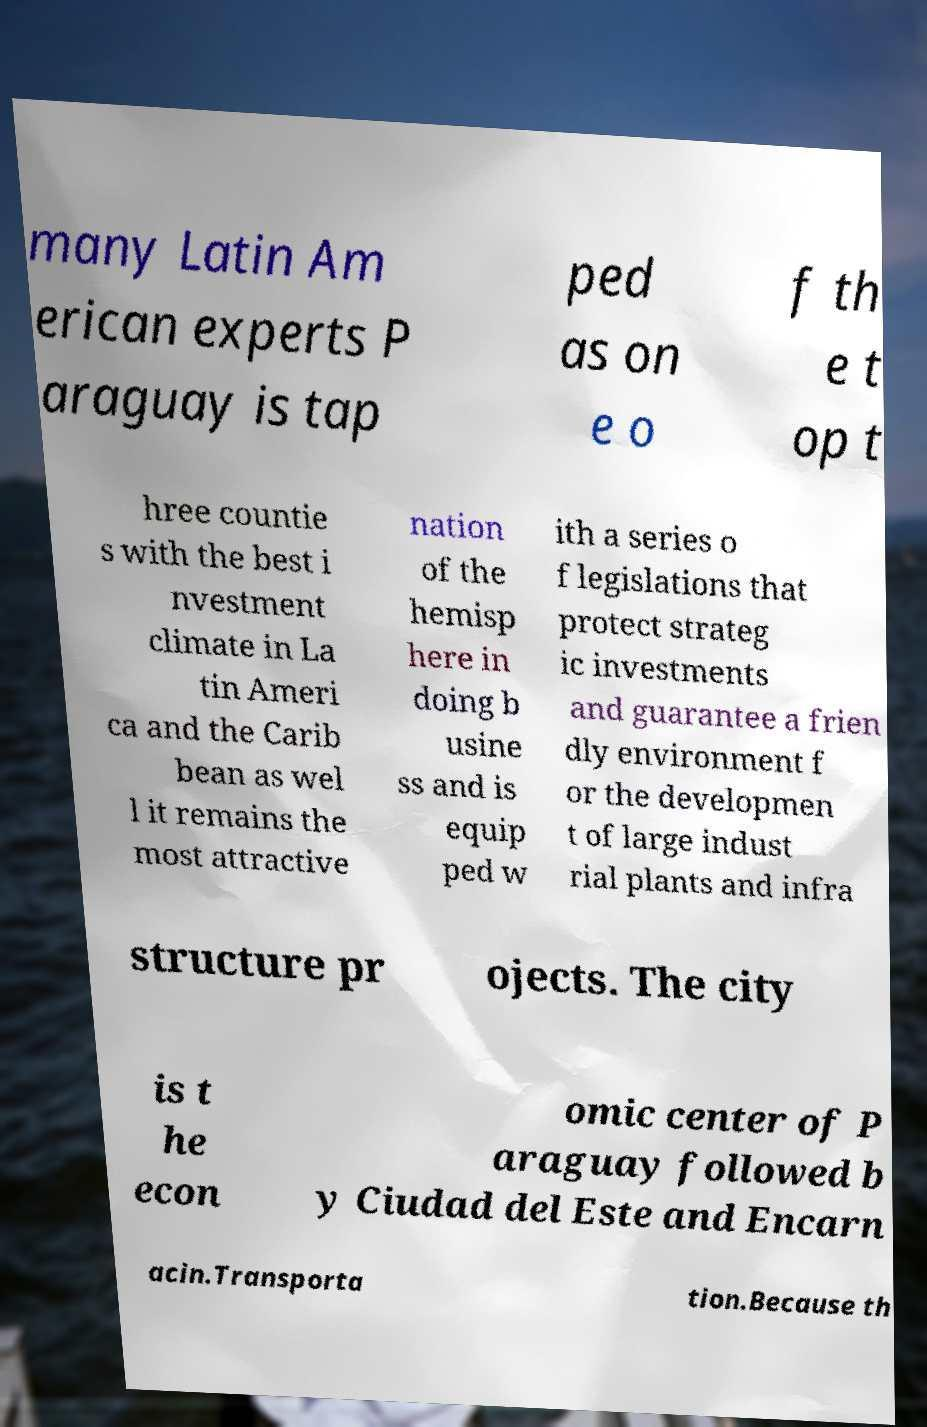For documentation purposes, I need the text within this image transcribed. Could you provide that? many Latin Am erican experts P araguay is tap ped as on e o f th e t op t hree countie s with the best i nvestment climate in La tin Ameri ca and the Carib bean as wel l it remains the most attractive nation of the hemisp here in doing b usine ss and is equip ped w ith a series o f legislations that protect strateg ic investments and guarantee a frien dly environment f or the developmen t of large indust rial plants and infra structure pr ojects. The city is t he econ omic center of P araguay followed b y Ciudad del Este and Encarn acin.Transporta tion.Because th 